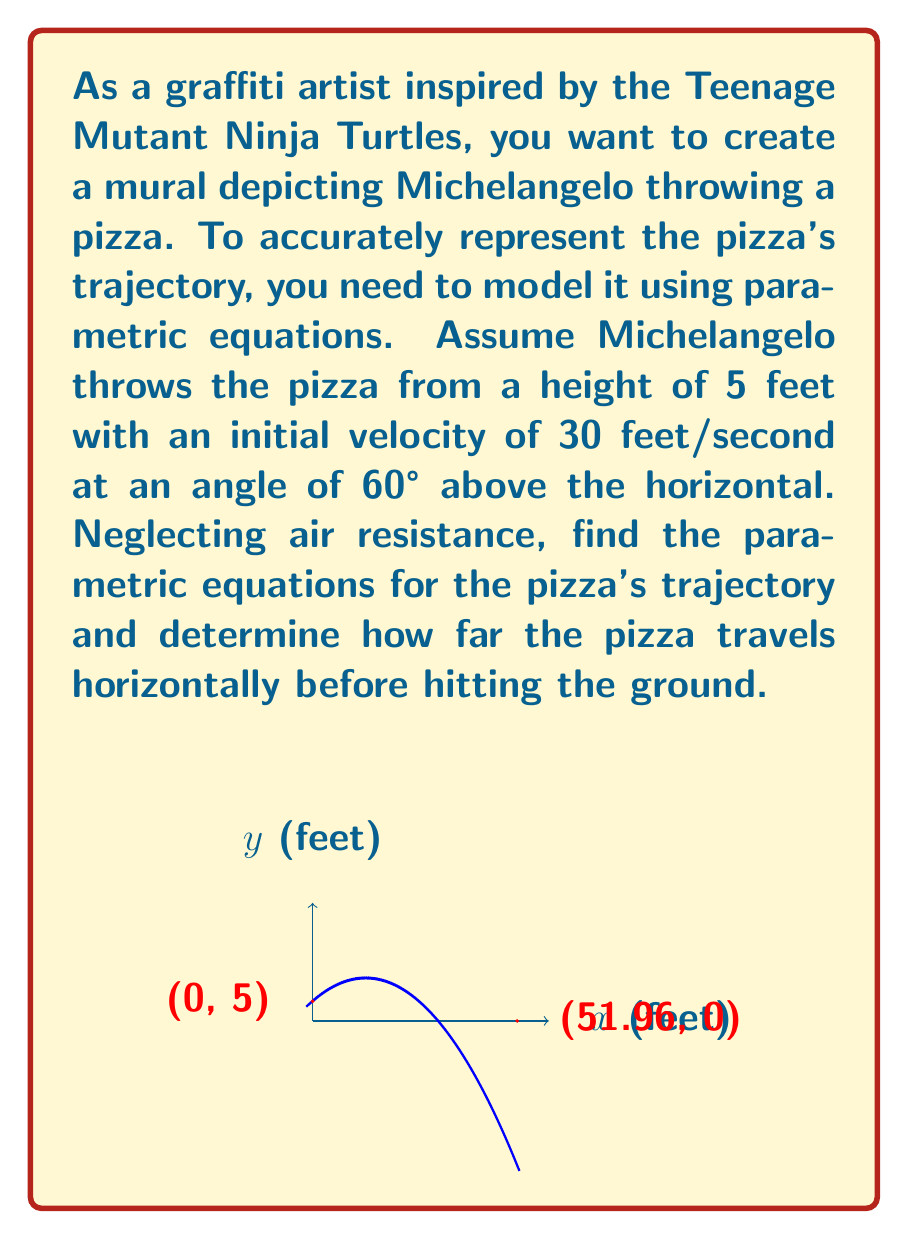Show me your answer to this math problem. Let's approach this step-by-step:

1) The parametric equations for projectile motion are:

   $x(t) = v_0 \cos(\theta) t$
   $y(t) = v_0 \sin(\theta) t - \frac{1}{2}gt^2 + y_0$

   Where $v_0$ is the initial velocity, $\theta$ is the angle of projection, $g$ is the acceleration due to gravity (32.2 ft/s²), and $y_0$ is the initial height.

2) Given:
   $v_0 = 30$ ft/s
   $\theta = 60°$
   $y_0 = 5$ ft

3) Let's substitute these values:

   $x(t) = 30 \cos(60°) t = 15t$
   $y(t) = 30 \sin(60°) t - \frac{1}{2}(32.2)t^2 + 5$
   $y(t) = 25.98t - 16.1t^2 + 5$

4) To find how far the pizza travels horizontally, we need to find when $y(t) = 0$:

   $0 = 25.98t - 16.1t^2 + 5$
   $16.1t^2 - 25.98t - 5 = 0$

5) Solve this quadratic equation:
   
   $t = \frac{25.98 \pm \sqrt{25.98^2 + 4(16.1)(5)}}{2(16.1)}$
   $t = 1.732$ or $t = -0.179$ (discard negative solution)

6) Now, substitute this t-value into $x(t)$:

   $x(1.732) = 15(1.732) = 25.98$ ft

Therefore, the pizza travels approximately 25.98 feet horizontally before hitting the ground.
Answer: Parametric equations: $x(t) = 15t$, $y(t) = 25.98t - 16.1t^2 + 5$. Horizontal distance: 25.98 ft. 